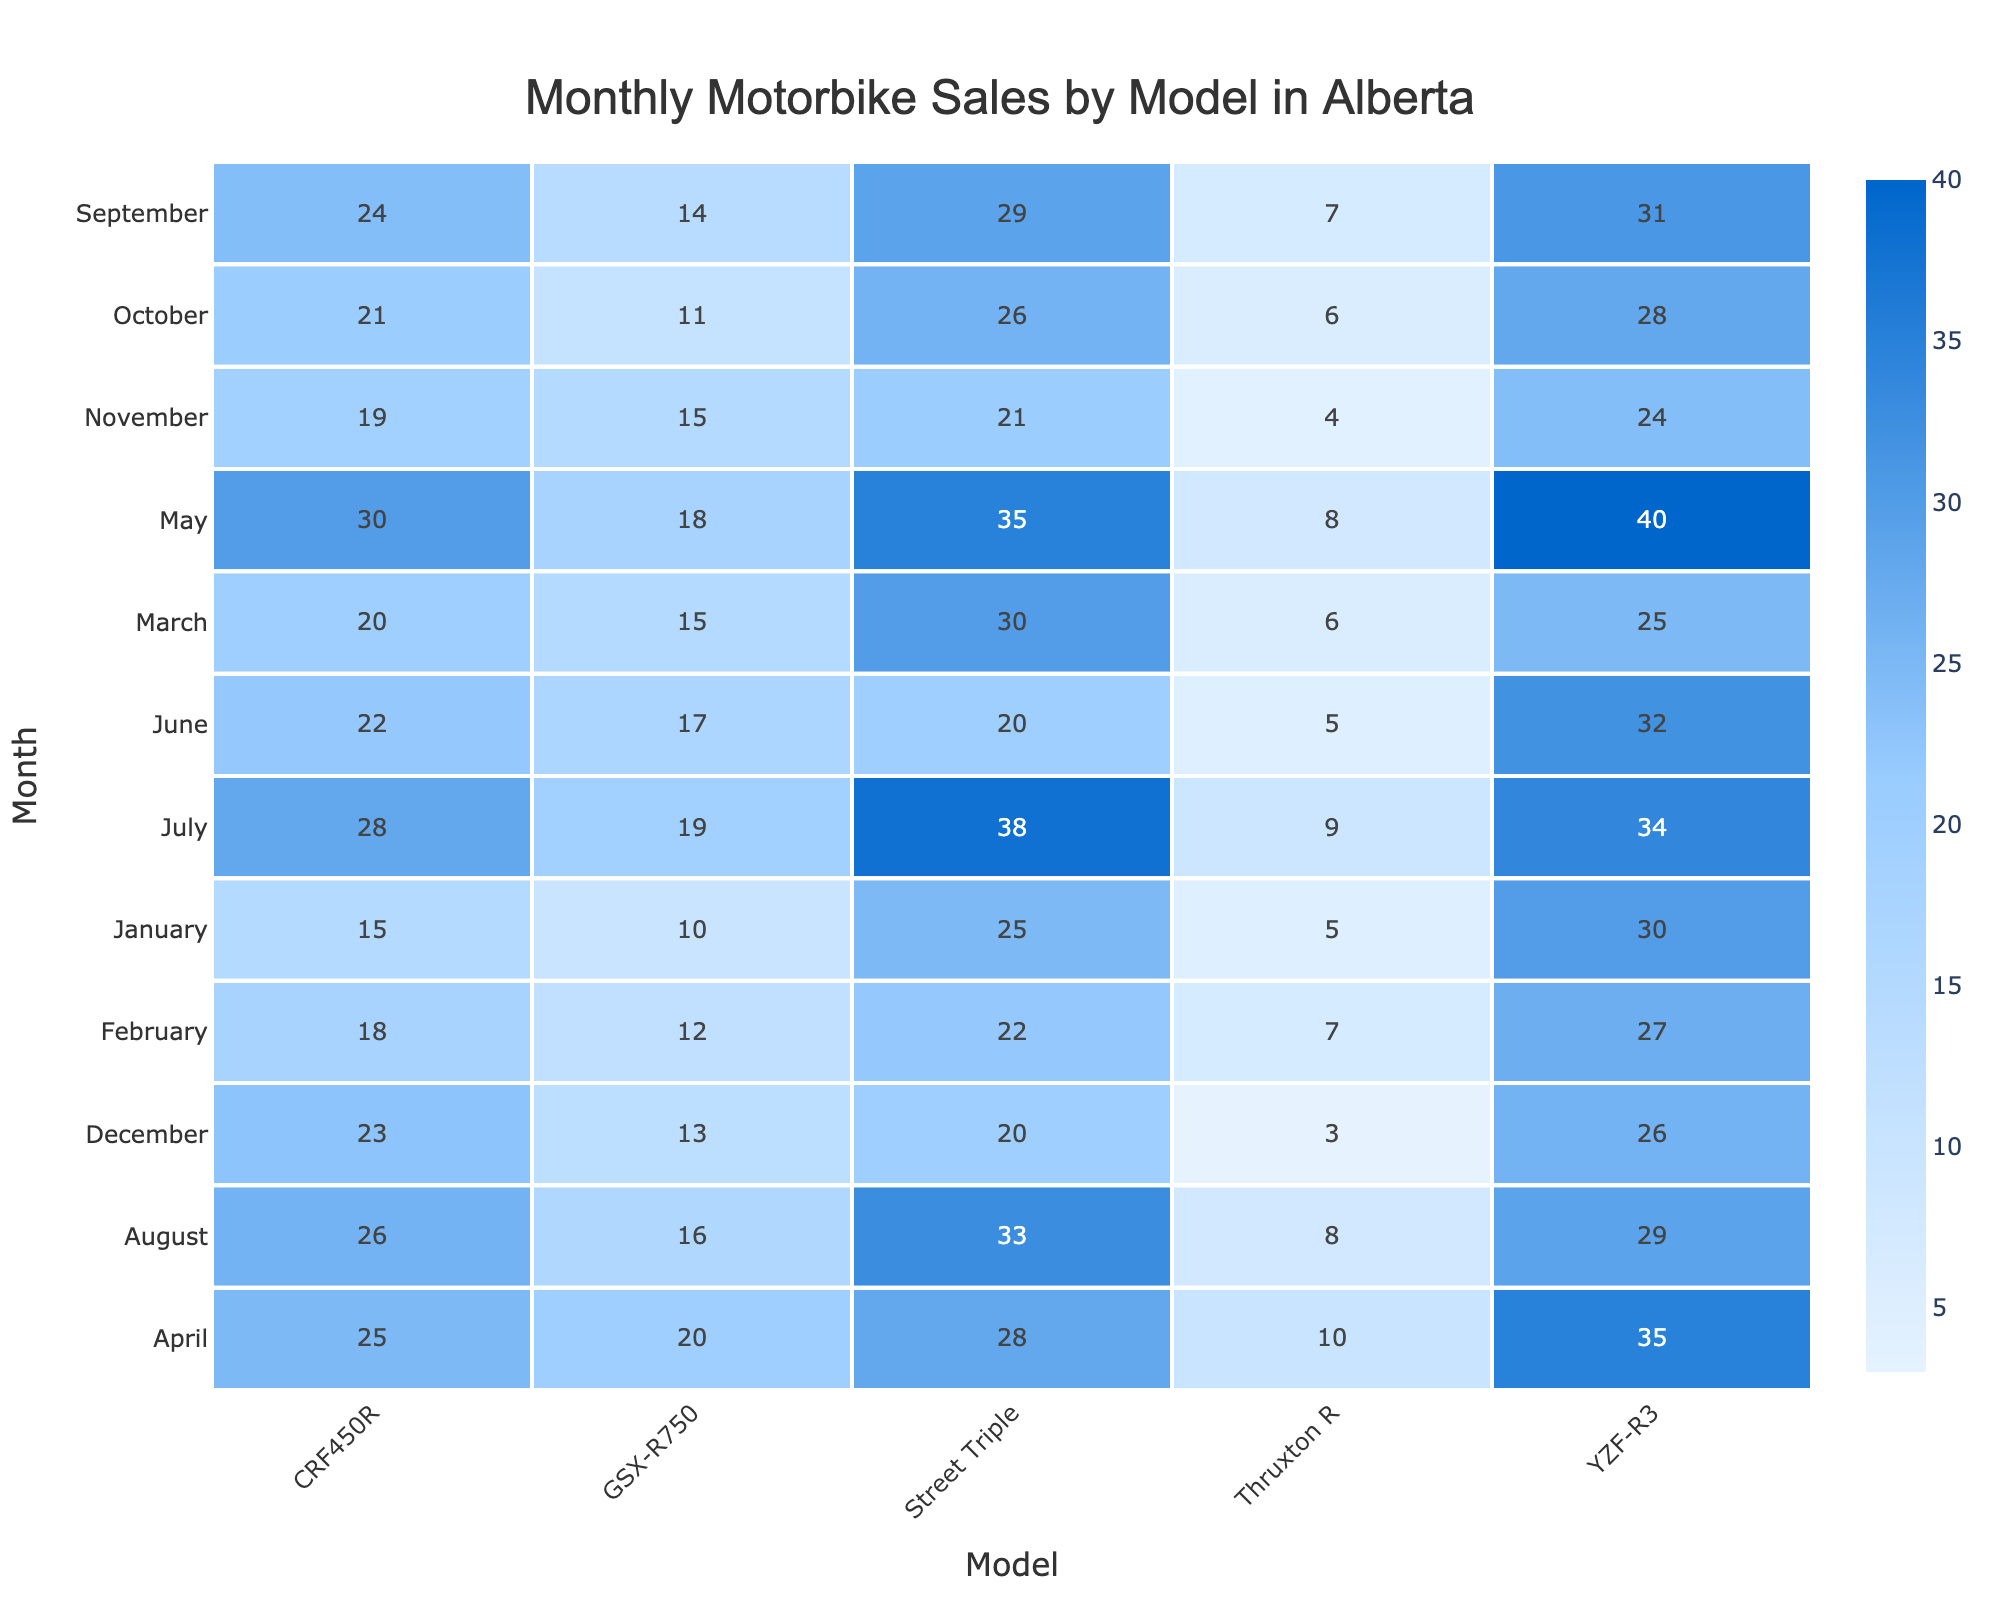What model sold the most units in May? In May, the YZF-R3 model sold 40 units, which is the highest of all models for that month when compared to CRF450R at 30, GSX-R750 at 18, Street Triple at 35, and Thruxton R at 8.
Answer: YZF-R3 How many units of the Street Triple were sold in March? In March, the table shows that 30 units of the Street Triple were sold.
Answer: 30 Which month had the highest sales for the CRF450R? The month of April had the highest sales for the CRF450R with 25 units sold, compared to January (15), February (18), March (20), May (30), June (22), July (28), August (26), September (24), October (21), November (19), and December (23).
Answer: April What is the average number of units sold for the Thruxton R across all months? Adding the units sold for Thruxton R for each month: 5 + 7 + 6 + 10 + 8 + 5 + 9 + 8 + 7 + 6 + 4 + 3 = 6.25. There are 12 months, so the average is 75 / 12 = 6.25.
Answer: 6.25 Did the GSX-R750 ever sell more than 20 units in a month? The data shows that the GSX-R750 sold 20 units in April, and the highest it reached, as per the table, is 20; hence, it did not exceed 20 units in any month.
Answer: No What is the total number of units sold for the YZF-R3 across the year? Summing the units sold: 30 + 27 + 25 + 35 + 40 + 32 + 34 + 29 + 31 + 28 + 24 + 26 adds up to 392.
Answer: 392 Which month had the lowest total sales across all models? Calculating total sales for each month: January (15 + 30 + 10 + 25 + 5 = 85), February (18 + 27 + 12 + 22 + 7 = 86), March (20 + 25 + 15 + 30 + 6 = 96), April (25 + 35 + 20 + 28 + 10 = 118), May (30 + 40 + 18 + 35 + 8 = 131), June (22 + 32 + 17 + 20 + 5 = 96), July (28 + 34 + 19 + 38 + 9 = 128), August (26 + 29 + 16 + 33 + 8 = 112), September (24 + 31 + 14 + 29 + 7 = 105), October (21 + 28 + 11 + 26 + 6 = 92), November (19 + 24 + 15 + 21 + 4 = 83), December (23 + 26 + 13 + 20 + 3 = 85). The lowest total sales occurred in November at 83.
Answer: November If we compare the sales of GSX-R750 and Thruxton R in October, which model sold more? In October, the GSX-R750 sold 11 units, while the Thruxton R only sold 6 units, thus the GSX-R750 sold more.
Answer: GSX-R750 What percentage of total units sold in December were from the YZF-R3? In December, there were 26 units sold for YZF-R3 along with the total units sold being 23 + 26 + 13 + 20 + 3 = 85. Thus, (26 / 85) * 100 = 30.59%.
Answer: 30.59% 